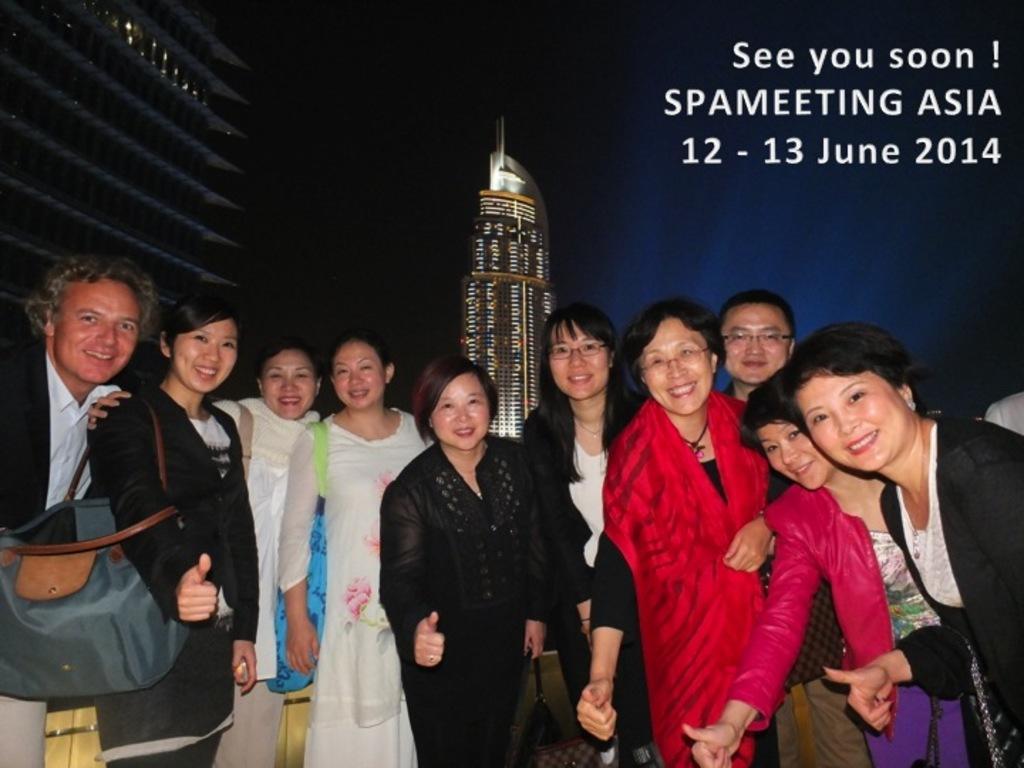Please provide a concise description of this image. In this picture I can see there are a group of people standing and they are smiling. In the backdrop there are two buildings. 